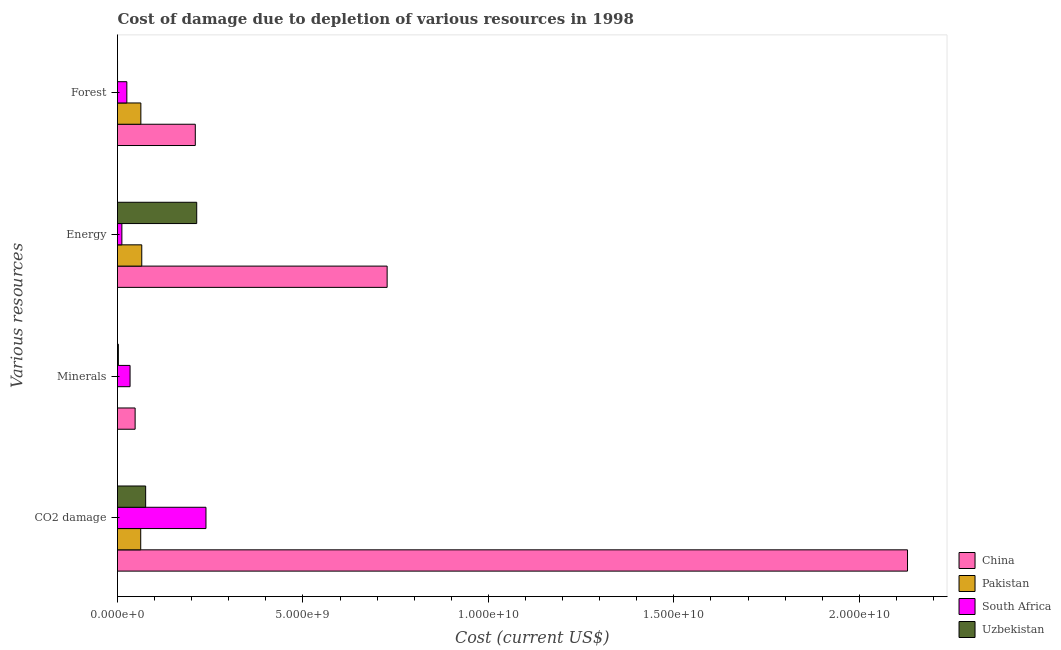Are the number of bars on each tick of the Y-axis equal?
Give a very brief answer. Yes. How many bars are there on the 2nd tick from the top?
Offer a very short reply. 4. What is the label of the 4th group of bars from the top?
Make the answer very short. CO2 damage. What is the cost of damage due to depletion of minerals in Pakistan?
Give a very brief answer. 3.19e+04. Across all countries, what is the maximum cost of damage due to depletion of coal?
Ensure brevity in your answer.  2.13e+1. Across all countries, what is the minimum cost of damage due to depletion of energy?
Provide a short and direct response. 1.18e+08. In which country was the cost of damage due to depletion of minerals maximum?
Offer a very short reply. China. In which country was the cost of damage due to depletion of forests minimum?
Your answer should be compact. Uzbekistan. What is the total cost of damage due to depletion of minerals in the graph?
Give a very brief answer. 8.37e+08. What is the difference between the cost of damage due to depletion of forests in Uzbekistan and that in South Africa?
Give a very brief answer. -2.51e+08. What is the difference between the cost of damage due to depletion of minerals in Pakistan and the cost of damage due to depletion of energy in Uzbekistan?
Keep it short and to the point. -2.14e+09. What is the average cost of damage due to depletion of coal per country?
Your response must be concise. 6.27e+09. What is the difference between the cost of damage due to depletion of minerals and cost of damage due to depletion of forests in South Africa?
Keep it short and to the point. 8.70e+07. In how many countries, is the cost of damage due to depletion of coal greater than 5000000000 US$?
Provide a short and direct response. 1. What is the ratio of the cost of damage due to depletion of forests in Uzbekistan to that in South Africa?
Provide a succinct answer. 0. Is the difference between the cost of damage due to depletion of minerals in Pakistan and South Africa greater than the difference between the cost of damage due to depletion of energy in Pakistan and South Africa?
Your response must be concise. No. What is the difference between the highest and the second highest cost of damage due to depletion of energy?
Your answer should be compact. 5.13e+09. What is the difference between the highest and the lowest cost of damage due to depletion of minerals?
Ensure brevity in your answer.  4.75e+08. In how many countries, is the cost of damage due to depletion of forests greater than the average cost of damage due to depletion of forests taken over all countries?
Ensure brevity in your answer.  1. Is the sum of the cost of damage due to depletion of minerals in Pakistan and China greater than the maximum cost of damage due to depletion of coal across all countries?
Your answer should be compact. No. Is it the case that in every country, the sum of the cost of damage due to depletion of forests and cost of damage due to depletion of minerals is greater than the sum of cost of damage due to depletion of coal and cost of damage due to depletion of energy?
Give a very brief answer. No. What does the 2nd bar from the top in Forest represents?
Provide a succinct answer. South Africa. What does the 1st bar from the bottom in CO2 damage represents?
Your answer should be compact. China. How many countries are there in the graph?
Provide a short and direct response. 4. How many legend labels are there?
Offer a very short reply. 4. How are the legend labels stacked?
Offer a terse response. Vertical. What is the title of the graph?
Provide a short and direct response. Cost of damage due to depletion of various resources in 1998 . Does "Mauritius" appear as one of the legend labels in the graph?
Make the answer very short. No. What is the label or title of the X-axis?
Your answer should be very brief. Cost (current US$). What is the label or title of the Y-axis?
Provide a short and direct response. Various resources. What is the Cost (current US$) in China in CO2 damage?
Your answer should be compact. 2.13e+1. What is the Cost (current US$) of Pakistan in CO2 damage?
Give a very brief answer. 6.26e+08. What is the Cost (current US$) in South Africa in CO2 damage?
Offer a very short reply. 2.38e+09. What is the Cost (current US$) of Uzbekistan in CO2 damage?
Offer a very short reply. 7.59e+08. What is the Cost (current US$) of China in Minerals?
Offer a terse response. 4.75e+08. What is the Cost (current US$) of Pakistan in Minerals?
Ensure brevity in your answer.  3.19e+04. What is the Cost (current US$) of South Africa in Minerals?
Ensure brevity in your answer.  3.39e+08. What is the Cost (current US$) in Uzbekistan in Minerals?
Ensure brevity in your answer.  2.31e+07. What is the Cost (current US$) of China in Energy?
Give a very brief answer. 7.27e+09. What is the Cost (current US$) of Pakistan in Energy?
Provide a succinct answer. 6.54e+08. What is the Cost (current US$) of South Africa in Energy?
Provide a short and direct response. 1.18e+08. What is the Cost (current US$) of Uzbekistan in Energy?
Offer a terse response. 2.14e+09. What is the Cost (current US$) of China in Forest?
Provide a succinct answer. 2.10e+09. What is the Cost (current US$) of Pakistan in Forest?
Offer a very short reply. 6.30e+08. What is the Cost (current US$) of South Africa in Forest?
Offer a terse response. 2.52e+08. What is the Cost (current US$) in Uzbekistan in Forest?
Your response must be concise. 4.96e+05. Across all Various resources, what is the maximum Cost (current US$) in China?
Offer a very short reply. 2.13e+1. Across all Various resources, what is the maximum Cost (current US$) of Pakistan?
Your answer should be very brief. 6.54e+08. Across all Various resources, what is the maximum Cost (current US$) in South Africa?
Offer a very short reply. 2.38e+09. Across all Various resources, what is the maximum Cost (current US$) in Uzbekistan?
Your answer should be compact. 2.14e+09. Across all Various resources, what is the minimum Cost (current US$) of China?
Your answer should be compact. 4.75e+08. Across all Various resources, what is the minimum Cost (current US$) in Pakistan?
Give a very brief answer. 3.19e+04. Across all Various resources, what is the minimum Cost (current US$) of South Africa?
Provide a succinct answer. 1.18e+08. Across all Various resources, what is the minimum Cost (current US$) of Uzbekistan?
Offer a terse response. 4.96e+05. What is the total Cost (current US$) in China in the graph?
Offer a very short reply. 3.11e+1. What is the total Cost (current US$) in Pakistan in the graph?
Offer a terse response. 1.91e+09. What is the total Cost (current US$) in South Africa in the graph?
Your answer should be compact. 3.09e+09. What is the total Cost (current US$) of Uzbekistan in the graph?
Provide a short and direct response. 2.92e+09. What is the difference between the Cost (current US$) in China in CO2 damage and that in Minerals?
Your response must be concise. 2.08e+1. What is the difference between the Cost (current US$) of Pakistan in CO2 damage and that in Minerals?
Offer a very short reply. 6.26e+08. What is the difference between the Cost (current US$) of South Africa in CO2 damage and that in Minerals?
Offer a terse response. 2.05e+09. What is the difference between the Cost (current US$) of Uzbekistan in CO2 damage and that in Minerals?
Provide a succinct answer. 7.36e+08. What is the difference between the Cost (current US$) of China in CO2 damage and that in Energy?
Ensure brevity in your answer.  1.40e+1. What is the difference between the Cost (current US$) of Pakistan in CO2 damage and that in Energy?
Give a very brief answer. -2.84e+07. What is the difference between the Cost (current US$) in South Africa in CO2 damage and that in Energy?
Provide a succinct answer. 2.27e+09. What is the difference between the Cost (current US$) in Uzbekistan in CO2 damage and that in Energy?
Offer a very short reply. -1.38e+09. What is the difference between the Cost (current US$) of China in CO2 damage and that in Forest?
Give a very brief answer. 1.92e+1. What is the difference between the Cost (current US$) of Pakistan in CO2 damage and that in Forest?
Make the answer very short. -4.11e+06. What is the difference between the Cost (current US$) of South Africa in CO2 damage and that in Forest?
Offer a terse response. 2.13e+09. What is the difference between the Cost (current US$) of Uzbekistan in CO2 damage and that in Forest?
Your response must be concise. 7.59e+08. What is the difference between the Cost (current US$) in China in Minerals and that in Energy?
Provide a succinct answer. -6.79e+09. What is the difference between the Cost (current US$) of Pakistan in Minerals and that in Energy?
Provide a short and direct response. -6.54e+08. What is the difference between the Cost (current US$) in South Africa in Minerals and that in Energy?
Offer a terse response. 2.21e+08. What is the difference between the Cost (current US$) of Uzbekistan in Minerals and that in Energy?
Keep it short and to the point. -2.11e+09. What is the difference between the Cost (current US$) in China in Minerals and that in Forest?
Provide a short and direct response. -1.62e+09. What is the difference between the Cost (current US$) in Pakistan in Minerals and that in Forest?
Your answer should be compact. -6.30e+08. What is the difference between the Cost (current US$) in South Africa in Minerals and that in Forest?
Your answer should be very brief. 8.70e+07. What is the difference between the Cost (current US$) of Uzbekistan in Minerals and that in Forest?
Your response must be concise. 2.26e+07. What is the difference between the Cost (current US$) of China in Energy and that in Forest?
Your answer should be compact. 5.17e+09. What is the difference between the Cost (current US$) of Pakistan in Energy and that in Forest?
Ensure brevity in your answer.  2.43e+07. What is the difference between the Cost (current US$) in South Africa in Energy and that in Forest?
Ensure brevity in your answer.  -1.34e+08. What is the difference between the Cost (current US$) of Uzbekistan in Energy and that in Forest?
Give a very brief answer. 2.14e+09. What is the difference between the Cost (current US$) of China in CO2 damage and the Cost (current US$) of Pakistan in Minerals?
Provide a short and direct response. 2.13e+1. What is the difference between the Cost (current US$) of China in CO2 damage and the Cost (current US$) of South Africa in Minerals?
Provide a succinct answer. 2.10e+1. What is the difference between the Cost (current US$) of China in CO2 damage and the Cost (current US$) of Uzbekistan in Minerals?
Offer a terse response. 2.13e+1. What is the difference between the Cost (current US$) in Pakistan in CO2 damage and the Cost (current US$) in South Africa in Minerals?
Your answer should be very brief. 2.87e+08. What is the difference between the Cost (current US$) in Pakistan in CO2 damage and the Cost (current US$) in Uzbekistan in Minerals?
Provide a short and direct response. 6.03e+08. What is the difference between the Cost (current US$) of South Africa in CO2 damage and the Cost (current US$) of Uzbekistan in Minerals?
Provide a succinct answer. 2.36e+09. What is the difference between the Cost (current US$) in China in CO2 damage and the Cost (current US$) in Pakistan in Energy?
Offer a terse response. 2.06e+1. What is the difference between the Cost (current US$) in China in CO2 damage and the Cost (current US$) in South Africa in Energy?
Your answer should be compact. 2.12e+1. What is the difference between the Cost (current US$) in China in CO2 damage and the Cost (current US$) in Uzbekistan in Energy?
Keep it short and to the point. 1.92e+1. What is the difference between the Cost (current US$) in Pakistan in CO2 damage and the Cost (current US$) in South Africa in Energy?
Give a very brief answer. 5.08e+08. What is the difference between the Cost (current US$) in Pakistan in CO2 damage and the Cost (current US$) in Uzbekistan in Energy?
Your answer should be very brief. -1.51e+09. What is the difference between the Cost (current US$) of South Africa in CO2 damage and the Cost (current US$) of Uzbekistan in Energy?
Your answer should be very brief. 2.49e+08. What is the difference between the Cost (current US$) in China in CO2 damage and the Cost (current US$) in Pakistan in Forest?
Your answer should be compact. 2.07e+1. What is the difference between the Cost (current US$) in China in CO2 damage and the Cost (current US$) in South Africa in Forest?
Keep it short and to the point. 2.10e+1. What is the difference between the Cost (current US$) in China in CO2 damage and the Cost (current US$) in Uzbekistan in Forest?
Provide a succinct answer. 2.13e+1. What is the difference between the Cost (current US$) in Pakistan in CO2 damage and the Cost (current US$) in South Africa in Forest?
Give a very brief answer. 3.74e+08. What is the difference between the Cost (current US$) in Pakistan in CO2 damage and the Cost (current US$) in Uzbekistan in Forest?
Offer a very short reply. 6.25e+08. What is the difference between the Cost (current US$) of South Africa in CO2 damage and the Cost (current US$) of Uzbekistan in Forest?
Give a very brief answer. 2.38e+09. What is the difference between the Cost (current US$) in China in Minerals and the Cost (current US$) in Pakistan in Energy?
Your answer should be very brief. -1.79e+08. What is the difference between the Cost (current US$) of China in Minerals and the Cost (current US$) of South Africa in Energy?
Offer a terse response. 3.57e+08. What is the difference between the Cost (current US$) of China in Minerals and the Cost (current US$) of Uzbekistan in Energy?
Offer a very short reply. -1.66e+09. What is the difference between the Cost (current US$) in Pakistan in Minerals and the Cost (current US$) in South Africa in Energy?
Provide a short and direct response. -1.18e+08. What is the difference between the Cost (current US$) of Pakistan in Minerals and the Cost (current US$) of Uzbekistan in Energy?
Your response must be concise. -2.14e+09. What is the difference between the Cost (current US$) in South Africa in Minerals and the Cost (current US$) in Uzbekistan in Energy?
Provide a succinct answer. -1.80e+09. What is the difference between the Cost (current US$) in China in Minerals and the Cost (current US$) in Pakistan in Forest?
Offer a terse response. -1.55e+08. What is the difference between the Cost (current US$) of China in Minerals and the Cost (current US$) of South Africa in Forest?
Provide a short and direct response. 2.23e+08. What is the difference between the Cost (current US$) in China in Minerals and the Cost (current US$) in Uzbekistan in Forest?
Give a very brief answer. 4.74e+08. What is the difference between the Cost (current US$) in Pakistan in Minerals and the Cost (current US$) in South Africa in Forest?
Ensure brevity in your answer.  -2.52e+08. What is the difference between the Cost (current US$) in Pakistan in Minerals and the Cost (current US$) in Uzbekistan in Forest?
Give a very brief answer. -4.64e+05. What is the difference between the Cost (current US$) of South Africa in Minerals and the Cost (current US$) of Uzbekistan in Forest?
Offer a terse response. 3.38e+08. What is the difference between the Cost (current US$) in China in Energy and the Cost (current US$) in Pakistan in Forest?
Keep it short and to the point. 6.64e+09. What is the difference between the Cost (current US$) of China in Energy and the Cost (current US$) of South Africa in Forest?
Your response must be concise. 7.02e+09. What is the difference between the Cost (current US$) of China in Energy and the Cost (current US$) of Uzbekistan in Forest?
Your answer should be very brief. 7.27e+09. What is the difference between the Cost (current US$) of Pakistan in Energy and the Cost (current US$) of South Africa in Forest?
Keep it short and to the point. 4.03e+08. What is the difference between the Cost (current US$) of Pakistan in Energy and the Cost (current US$) of Uzbekistan in Forest?
Give a very brief answer. 6.54e+08. What is the difference between the Cost (current US$) in South Africa in Energy and the Cost (current US$) in Uzbekistan in Forest?
Your answer should be compact. 1.17e+08. What is the average Cost (current US$) in China per Various resources?
Your response must be concise. 7.79e+09. What is the average Cost (current US$) of Pakistan per Various resources?
Offer a very short reply. 4.77e+08. What is the average Cost (current US$) in South Africa per Various resources?
Keep it short and to the point. 7.73e+08. What is the average Cost (current US$) in Uzbekistan per Various resources?
Give a very brief answer. 7.30e+08. What is the difference between the Cost (current US$) of China and Cost (current US$) of Pakistan in CO2 damage?
Ensure brevity in your answer.  2.07e+1. What is the difference between the Cost (current US$) of China and Cost (current US$) of South Africa in CO2 damage?
Give a very brief answer. 1.89e+1. What is the difference between the Cost (current US$) in China and Cost (current US$) in Uzbekistan in CO2 damage?
Provide a short and direct response. 2.05e+1. What is the difference between the Cost (current US$) of Pakistan and Cost (current US$) of South Africa in CO2 damage?
Provide a succinct answer. -1.76e+09. What is the difference between the Cost (current US$) in Pakistan and Cost (current US$) in Uzbekistan in CO2 damage?
Make the answer very short. -1.33e+08. What is the difference between the Cost (current US$) in South Africa and Cost (current US$) in Uzbekistan in CO2 damage?
Give a very brief answer. 1.63e+09. What is the difference between the Cost (current US$) of China and Cost (current US$) of Pakistan in Minerals?
Offer a very short reply. 4.75e+08. What is the difference between the Cost (current US$) in China and Cost (current US$) in South Africa in Minerals?
Your answer should be very brief. 1.36e+08. What is the difference between the Cost (current US$) in China and Cost (current US$) in Uzbekistan in Minerals?
Your response must be concise. 4.52e+08. What is the difference between the Cost (current US$) in Pakistan and Cost (current US$) in South Africa in Minerals?
Your answer should be very brief. -3.39e+08. What is the difference between the Cost (current US$) of Pakistan and Cost (current US$) of Uzbekistan in Minerals?
Offer a terse response. -2.31e+07. What is the difference between the Cost (current US$) in South Africa and Cost (current US$) in Uzbekistan in Minerals?
Your answer should be compact. 3.16e+08. What is the difference between the Cost (current US$) in China and Cost (current US$) in Pakistan in Energy?
Offer a very short reply. 6.62e+09. What is the difference between the Cost (current US$) in China and Cost (current US$) in South Africa in Energy?
Your response must be concise. 7.15e+09. What is the difference between the Cost (current US$) of China and Cost (current US$) of Uzbekistan in Energy?
Provide a succinct answer. 5.13e+09. What is the difference between the Cost (current US$) in Pakistan and Cost (current US$) in South Africa in Energy?
Make the answer very short. 5.36e+08. What is the difference between the Cost (current US$) of Pakistan and Cost (current US$) of Uzbekistan in Energy?
Your response must be concise. -1.48e+09. What is the difference between the Cost (current US$) in South Africa and Cost (current US$) in Uzbekistan in Energy?
Your response must be concise. -2.02e+09. What is the difference between the Cost (current US$) in China and Cost (current US$) in Pakistan in Forest?
Your response must be concise. 1.47e+09. What is the difference between the Cost (current US$) in China and Cost (current US$) in South Africa in Forest?
Your answer should be very brief. 1.85e+09. What is the difference between the Cost (current US$) of China and Cost (current US$) of Uzbekistan in Forest?
Your answer should be very brief. 2.10e+09. What is the difference between the Cost (current US$) of Pakistan and Cost (current US$) of South Africa in Forest?
Provide a succinct answer. 3.78e+08. What is the difference between the Cost (current US$) in Pakistan and Cost (current US$) in Uzbekistan in Forest?
Offer a terse response. 6.29e+08. What is the difference between the Cost (current US$) of South Africa and Cost (current US$) of Uzbekistan in Forest?
Keep it short and to the point. 2.51e+08. What is the ratio of the Cost (current US$) of China in CO2 damage to that in Minerals?
Ensure brevity in your answer.  44.84. What is the ratio of the Cost (current US$) in Pakistan in CO2 damage to that in Minerals?
Make the answer very short. 1.96e+04. What is the ratio of the Cost (current US$) in South Africa in CO2 damage to that in Minerals?
Provide a short and direct response. 7.04. What is the ratio of the Cost (current US$) in Uzbekistan in CO2 damage to that in Minerals?
Your answer should be very brief. 32.83. What is the ratio of the Cost (current US$) of China in CO2 damage to that in Energy?
Your answer should be very brief. 2.93. What is the ratio of the Cost (current US$) of Pakistan in CO2 damage to that in Energy?
Offer a very short reply. 0.96. What is the ratio of the Cost (current US$) of South Africa in CO2 damage to that in Energy?
Keep it short and to the point. 20.26. What is the ratio of the Cost (current US$) in Uzbekistan in CO2 damage to that in Energy?
Give a very brief answer. 0.36. What is the ratio of the Cost (current US$) in China in CO2 damage to that in Forest?
Provide a succinct answer. 10.15. What is the ratio of the Cost (current US$) in Pakistan in CO2 damage to that in Forest?
Your answer should be very brief. 0.99. What is the ratio of the Cost (current US$) of South Africa in CO2 damage to that in Forest?
Your answer should be very brief. 9.48. What is the ratio of the Cost (current US$) in Uzbekistan in CO2 damage to that in Forest?
Provide a succinct answer. 1529.19. What is the ratio of the Cost (current US$) of China in Minerals to that in Energy?
Make the answer very short. 0.07. What is the ratio of the Cost (current US$) in South Africa in Minerals to that in Energy?
Provide a succinct answer. 2.88. What is the ratio of the Cost (current US$) of Uzbekistan in Minerals to that in Energy?
Provide a succinct answer. 0.01. What is the ratio of the Cost (current US$) in China in Minerals to that in Forest?
Give a very brief answer. 0.23. What is the ratio of the Cost (current US$) in South Africa in Minerals to that in Forest?
Ensure brevity in your answer.  1.35. What is the ratio of the Cost (current US$) in Uzbekistan in Minerals to that in Forest?
Offer a very short reply. 46.57. What is the ratio of the Cost (current US$) of China in Energy to that in Forest?
Keep it short and to the point. 3.47. What is the ratio of the Cost (current US$) of Pakistan in Energy to that in Forest?
Your response must be concise. 1.04. What is the ratio of the Cost (current US$) in South Africa in Energy to that in Forest?
Keep it short and to the point. 0.47. What is the ratio of the Cost (current US$) in Uzbekistan in Energy to that in Forest?
Your answer should be compact. 4302.28. What is the difference between the highest and the second highest Cost (current US$) of China?
Offer a terse response. 1.40e+1. What is the difference between the highest and the second highest Cost (current US$) in Pakistan?
Provide a short and direct response. 2.43e+07. What is the difference between the highest and the second highest Cost (current US$) in South Africa?
Keep it short and to the point. 2.05e+09. What is the difference between the highest and the second highest Cost (current US$) in Uzbekistan?
Your response must be concise. 1.38e+09. What is the difference between the highest and the lowest Cost (current US$) in China?
Make the answer very short. 2.08e+1. What is the difference between the highest and the lowest Cost (current US$) in Pakistan?
Keep it short and to the point. 6.54e+08. What is the difference between the highest and the lowest Cost (current US$) of South Africa?
Provide a succinct answer. 2.27e+09. What is the difference between the highest and the lowest Cost (current US$) in Uzbekistan?
Your answer should be very brief. 2.14e+09. 